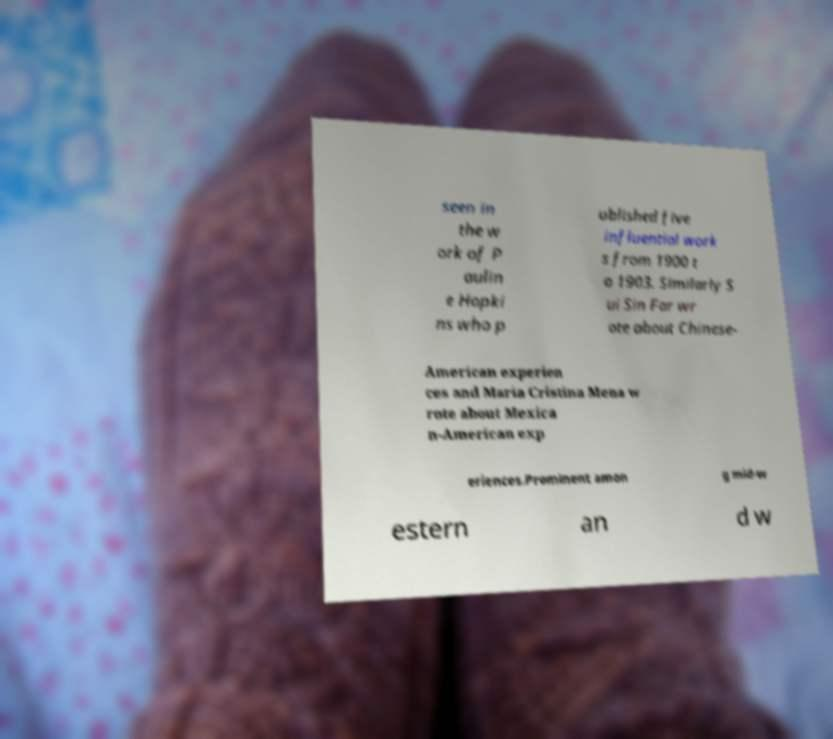Could you assist in decoding the text presented in this image and type it out clearly? seen in the w ork of P aulin e Hopki ns who p ublished five influential work s from 1900 t o 1903. Similarly S ui Sin Far wr ote about Chinese- American experien ces and Maria Cristina Mena w rote about Mexica n-American exp eriences.Prominent amon g mid-w estern an d w 